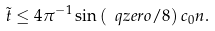Convert formula to latex. <formula><loc_0><loc_0><loc_500><loc_500>\tilde { t } \leq 4 \pi ^ { - 1 } \sin \left ( \ q z e r o / 8 \right ) c _ { 0 } n .</formula> 